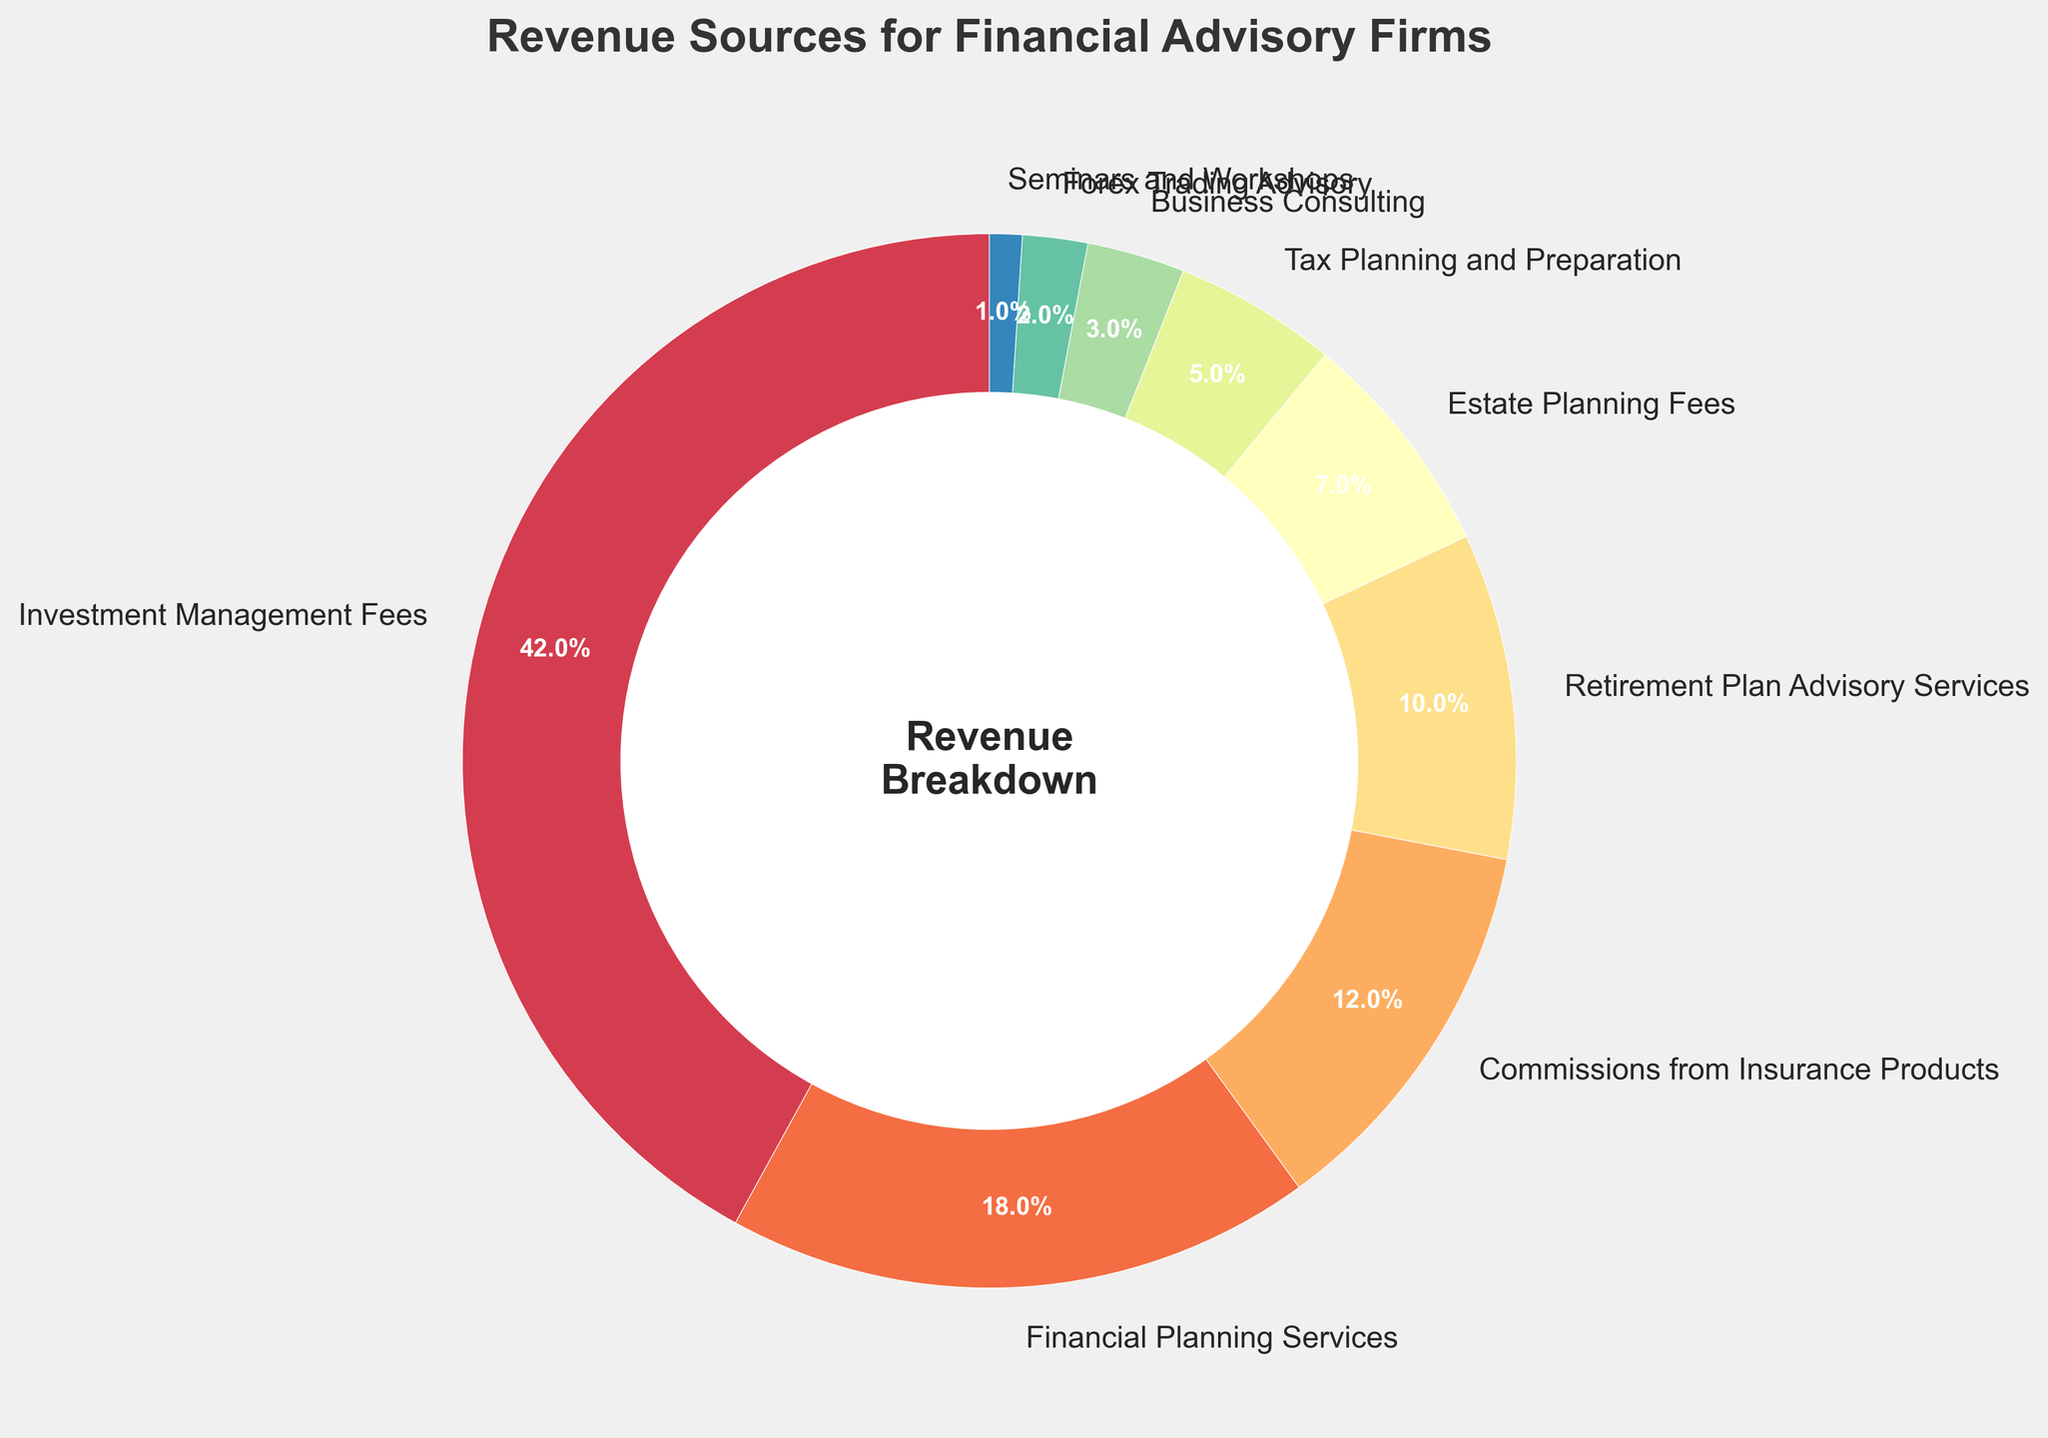What is the category with the highest percentage of revenue? Look at the segment with the largest area and the highest percentage label. "Investment Management Fees" has the highest percentage at 42%.
Answer: Investment Management Fees What is the total percentage of revenue from Financial Planning Services and Retirement Plan Advisory Services? Add the percentages of Financial Planning Services (18%) and Retirement Plan Advisory Services (10%). The total is 18% + 10% = 28%.
Answer: 28% Which revenue source contributes more: Estate Planning Fees or Tax Planning and Preparation? Compare the percentages of Estate Planning Fees (7%) and Tax Planning and Preparation (5%). Estate Planning Fees has a higher percentage.
Answer: Estate Planning Fees How much more does Commissions from Insurance Products contribute than Forex Trading Advisory? Subtract the percentage of Forex Trading Advisory (2%) from the percentage of Commissions from Insurance Products (12%). The difference is 12% - 2% = 10%.
Answer: 10% What is the combined percentage of the three smallest revenue sources? Identify the smallest percentages: Seminars and Workshops (1%), Forex Trading Advisory (2%), and Business Consulting (3%). Add them: 1% + 2% + 3% = 6%.
Answer: 6% How does the percentage of Investment Management Fees compare to the total of Commissions from Insurance Products and Financial Planning Services? Add Commissions from Insurance Products (12%) and Financial Planning Services (18%) to get 12% + 18% = 30%. Compare this to Investment Management Fees (42%). Investment Management Fees is greater.
Answer: Investment Management Fees is greater Which category is represented by the largest wedge in the pie chart? The largest wedge corresponds to Investment Management Fees, which is visually the largest segment.
Answer: Investment Management Fees If the top three categories are combined, what percentage of the total revenue does this represent? Identify the top three categories: Investment Management Fees (42%), Financial Planning Services (18%), and Commissions from Insurance Products (12%). Add: 42% + 18% + 12% = 72%.
Answer: 72% What is the difference in percentage between the largest and smallest revenue sources? Subtract the smallest percentage (Seminars and Workshops at 1%) from the largest (Investment Management Fees at 42%). The difference is 42% - 1% = 41%.
Answer: 41% Is the combined percentage of Estate Planning Fees and Retirement Plan Advisory Services less than Financial Planning Services? Add Estate Planning Fees (7%) and Retirement Plan Advisory Services (10%) to get 7% + 10% = 17%. Compare this to Financial Planning Services (18%). Yes, it is less.
Answer: Yes 